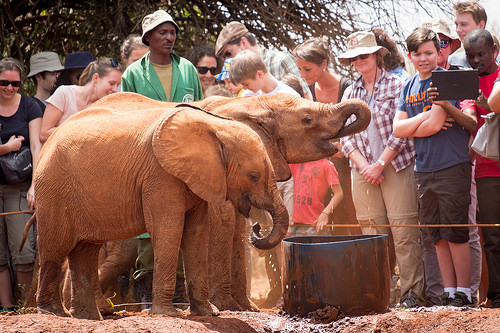<image>
Can you confirm if the elephant is to the left of the elephant? No. The elephant is not to the left of the elephant. From this viewpoint, they have a different horizontal relationship. 